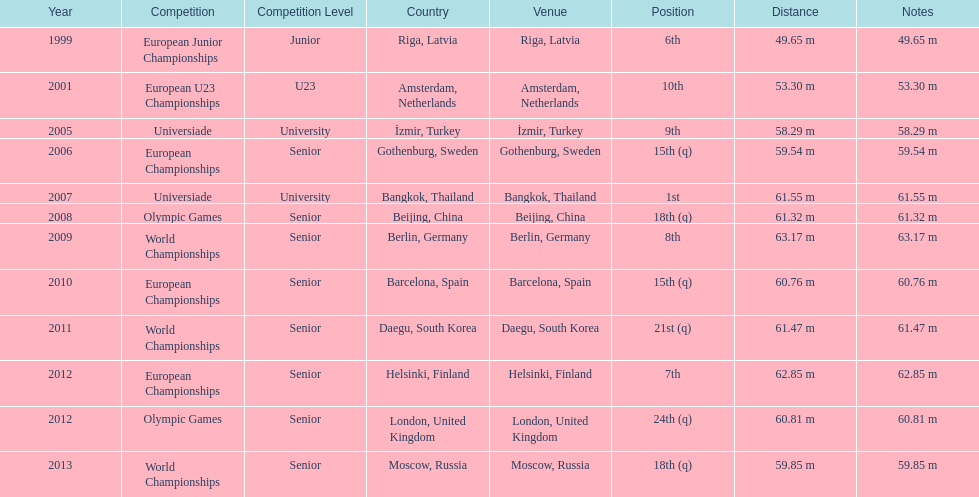How many world championships has he been in? 3. 